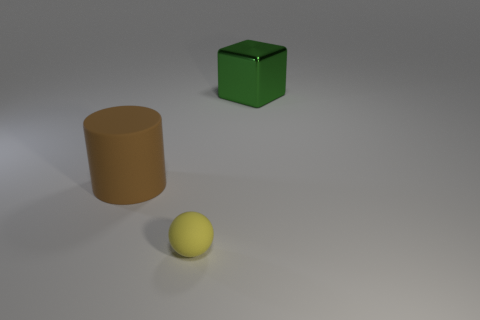Add 2 green shiny things. How many objects exist? 5 Add 3 big green objects. How many big green objects are left? 4 Add 3 tiny matte balls. How many tiny matte balls exist? 4 Subtract 0 brown blocks. How many objects are left? 3 Subtract all blocks. How many objects are left? 2 Subtract all tiny spheres. Subtract all large shiny things. How many objects are left? 1 